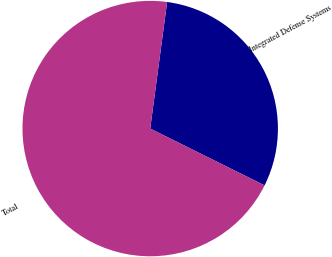Convert chart to OTSL. <chart><loc_0><loc_0><loc_500><loc_500><pie_chart><fcel>Integrated Defense Systems<fcel>Total<nl><fcel>30.22%<fcel>69.78%<nl></chart> 